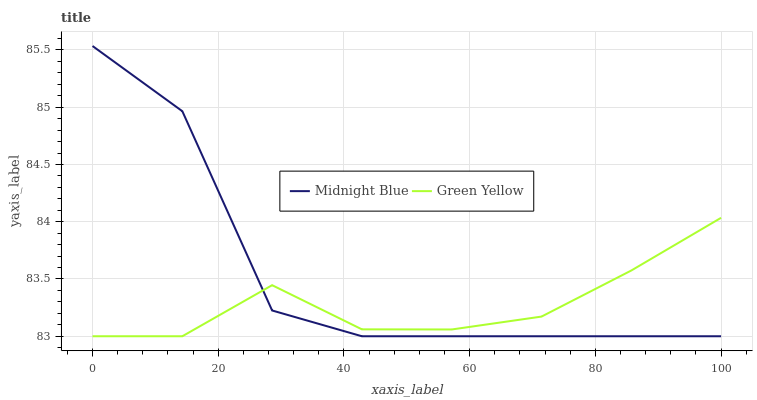Does Green Yellow have the minimum area under the curve?
Answer yes or no. Yes. Does Midnight Blue have the maximum area under the curve?
Answer yes or no. Yes. Does Midnight Blue have the minimum area under the curve?
Answer yes or no. No. Is Green Yellow the smoothest?
Answer yes or no. Yes. Is Midnight Blue the roughest?
Answer yes or no. Yes. Is Midnight Blue the smoothest?
Answer yes or no. No. Does Green Yellow have the lowest value?
Answer yes or no. Yes. Does Midnight Blue have the highest value?
Answer yes or no. Yes. Does Midnight Blue intersect Green Yellow?
Answer yes or no. Yes. Is Midnight Blue less than Green Yellow?
Answer yes or no. No. Is Midnight Blue greater than Green Yellow?
Answer yes or no. No. 